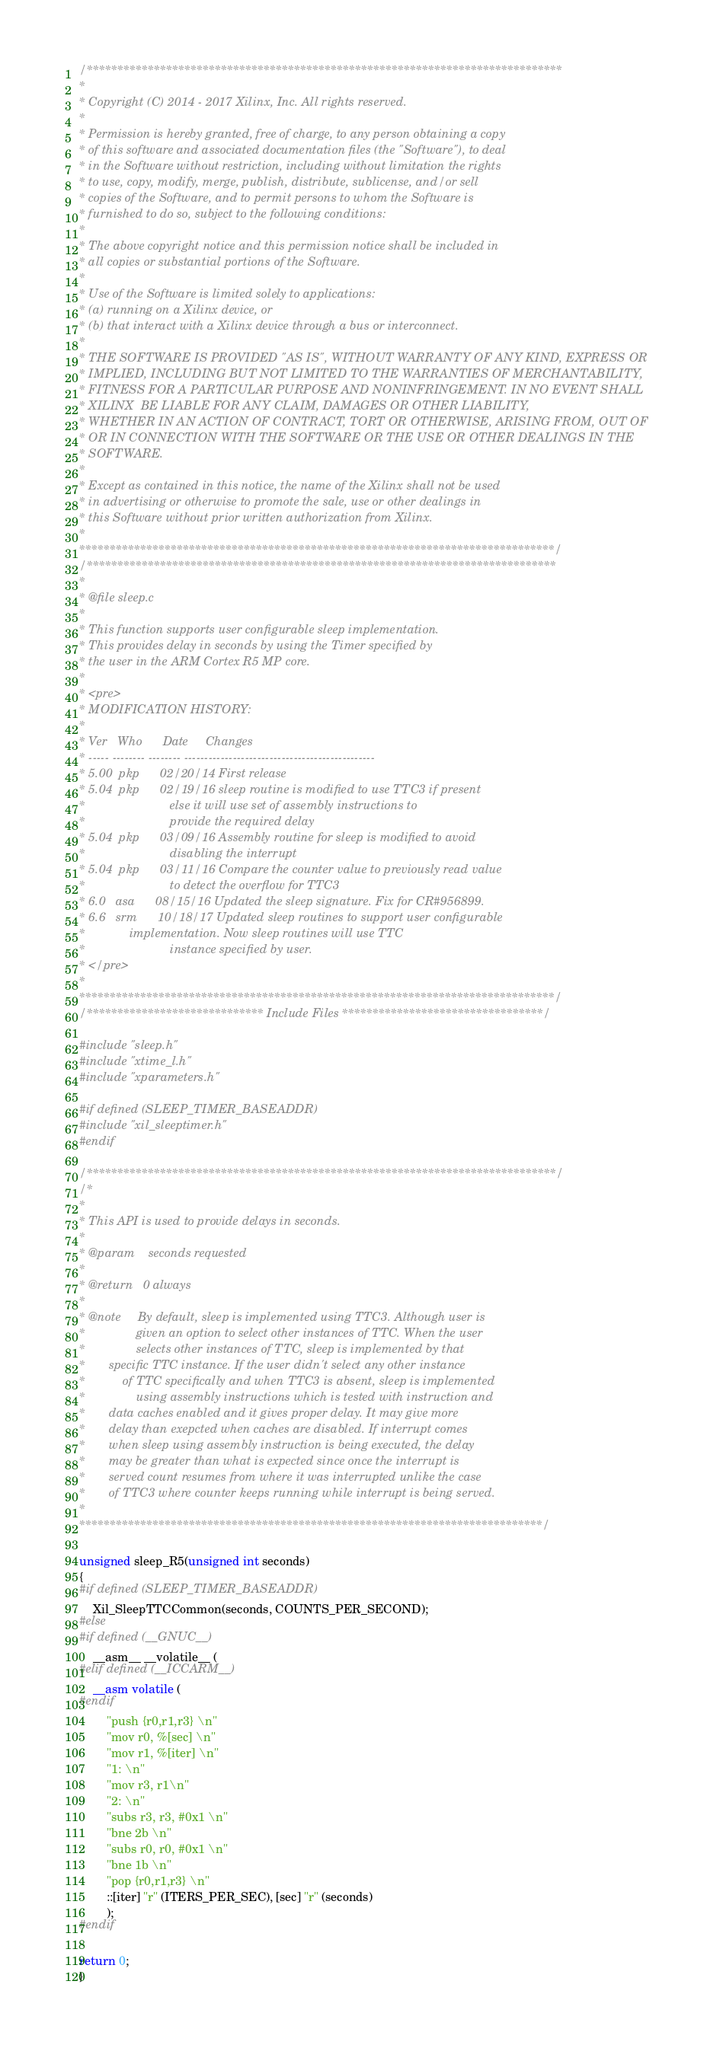Convert code to text. <code><loc_0><loc_0><loc_500><loc_500><_C_>/******************************************************************************
*
* Copyright (C) 2014 - 2017 Xilinx, Inc. All rights reserved.
*
* Permission is hereby granted, free of charge, to any person obtaining a copy
* of this software and associated documentation files (the "Software"), to deal
* in the Software without restriction, including without limitation the rights
* to use, copy, modify, merge, publish, distribute, sublicense, and/or sell
* copies of the Software, and to permit persons to whom the Software is
* furnished to do so, subject to the following conditions:
*
* The above copyright notice and this permission notice shall be included in
* all copies or substantial portions of the Software.
*
* Use of the Software is limited solely to applications:
* (a) running on a Xilinx device, or
* (b) that interact with a Xilinx device through a bus or interconnect.
*
* THE SOFTWARE IS PROVIDED "AS IS", WITHOUT WARRANTY OF ANY KIND, EXPRESS OR
* IMPLIED, INCLUDING BUT NOT LIMITED TO THE WARRANTIES OF MERCHANTABILITY,
* FITNESS FOR A PARTICULAR PURPOSE AND NONINFRINGEMENT. IN NO EVENT SHALL
* XILINX  BE LIABLE FOR ANY CLAIM, DAMAGES OR OTHER LIABILITY,
* WHETHER IN AN ACTION OF CONTRACT, TORT OR OTHERWISE, ARISING FROM, OUT OF
* OR IN CONNECTION WITH THE SOFTWARE OR THE USE OR OTHER DEALINGS IN THE
* SOFTWARE.
*
* Except as contained in this notice, the name of the Xilinx shall not be used
* in advertising or otherwise to promote the sale, use or other dealings in
* this Software without prior written authorization from Xilinx.
*
******************************************************************************/
/*****************************************************************************
*
* @file sleep.c
*
* This function supports user configurable sleep implementation.
* This provides delay in seconds by using the Timer specified by
* the user in the ARM Cortex R5 MP core.
*
* <pre>
* MODIFICATION HISTORY:
*
* Ver   Who      Date     Changes
* ----- -------- -------- -----------------------------------------------
* 5.00 	pkp  	 02/20/14 First release
* 5.04  pkp		 02/19/16 sleep routine is modified to use TTC3 if present
*						  else it will use set of assembly instructions to
*						  provide the required delay
* 5.04	pkp		 03/09/16 Assembly routine for sleep is modified to avoid
*						  disabling the interrupt
* 5.04	pkp		 03/11/16 Compare the counter value to previously read value
*						  to detect the overflow for TTC3
* 6.0   asa      08/15/16 Updated the sleep signature. Fix for CR#956899.
* 6.6	srm      10/18/17 Updated sleep routines to support user configurable
*			  implementation. Now sleep routines will use TTC
*                         instance specified by user.
* </pre>
*
******************************************************************************/
/***************************** Include Files *********************************/

#include "sleep.h"
#include "xtime_l.h"
#include "xparameters.h"

#if defined (SLEEP_TIMER_BASEADDR)
#include "xil_sleeptimer.h"
#endif

/*****************************************************************************/
/*
*
* This API is used to provide delays in seconds.
*
* @param	seconds requested
*
* @return	0 always
*
* @note		By default, sleep is implemented using TTC3. Although user is
*               given an option to select other instances of TTC. When the user
*               selects other instances of TTC, sleep is implemented by that
*		specific TTC instance. If the user didn't select any other instance
*	        of TTC specifically and when TTC3 is absent, sleep is implemented
*      	        using assembly instructions which is tested with instruction and
*		data caches enabled and it gives proper delay. It may give more
*		delay than exepcted when caches are disabled. If interrupt comes
*		when sleep using assembly instruction is being executed, the delay
*		may be greater than what is expected since once the interrupt is
*		served count resumes from where it was interrupted unlike the case
*		of TTC3 where counter keeps running while interrupt is being served.
*
****************************************************************************/

unsigned sleep_R5(unsigned int seconds)
{
#if defined (SLEEP_TIMER_BASEADDR)
	Xil_SleepTTCCommon(seconds, COUNTS_PER_SECOND);
#else
#if defined (__GNUC__)
	__asm__ __volatile__ (
#elif defined (__ICCARM__)
	__asm volatile (
#endif
		"push {r0,r1,r3} \n"
		"mov r0, %[sec] \n"
		"mov r1, %[iter] \n"
		"1: \n"
		"mov r3, r1\n"
		"2: \n"
		"subs r3, r3, #0x1 \n"
		"bne 2b \n"
		"subs r0, r0, #0x1 \n"
		"bne 1b \n"
		"pop {r0,r1,r3} \n"
		::[iter] "r" (ITERS_PER_SEC), [sec] "r" (seconds)
		);
#endif

return 0;
}
</code> 